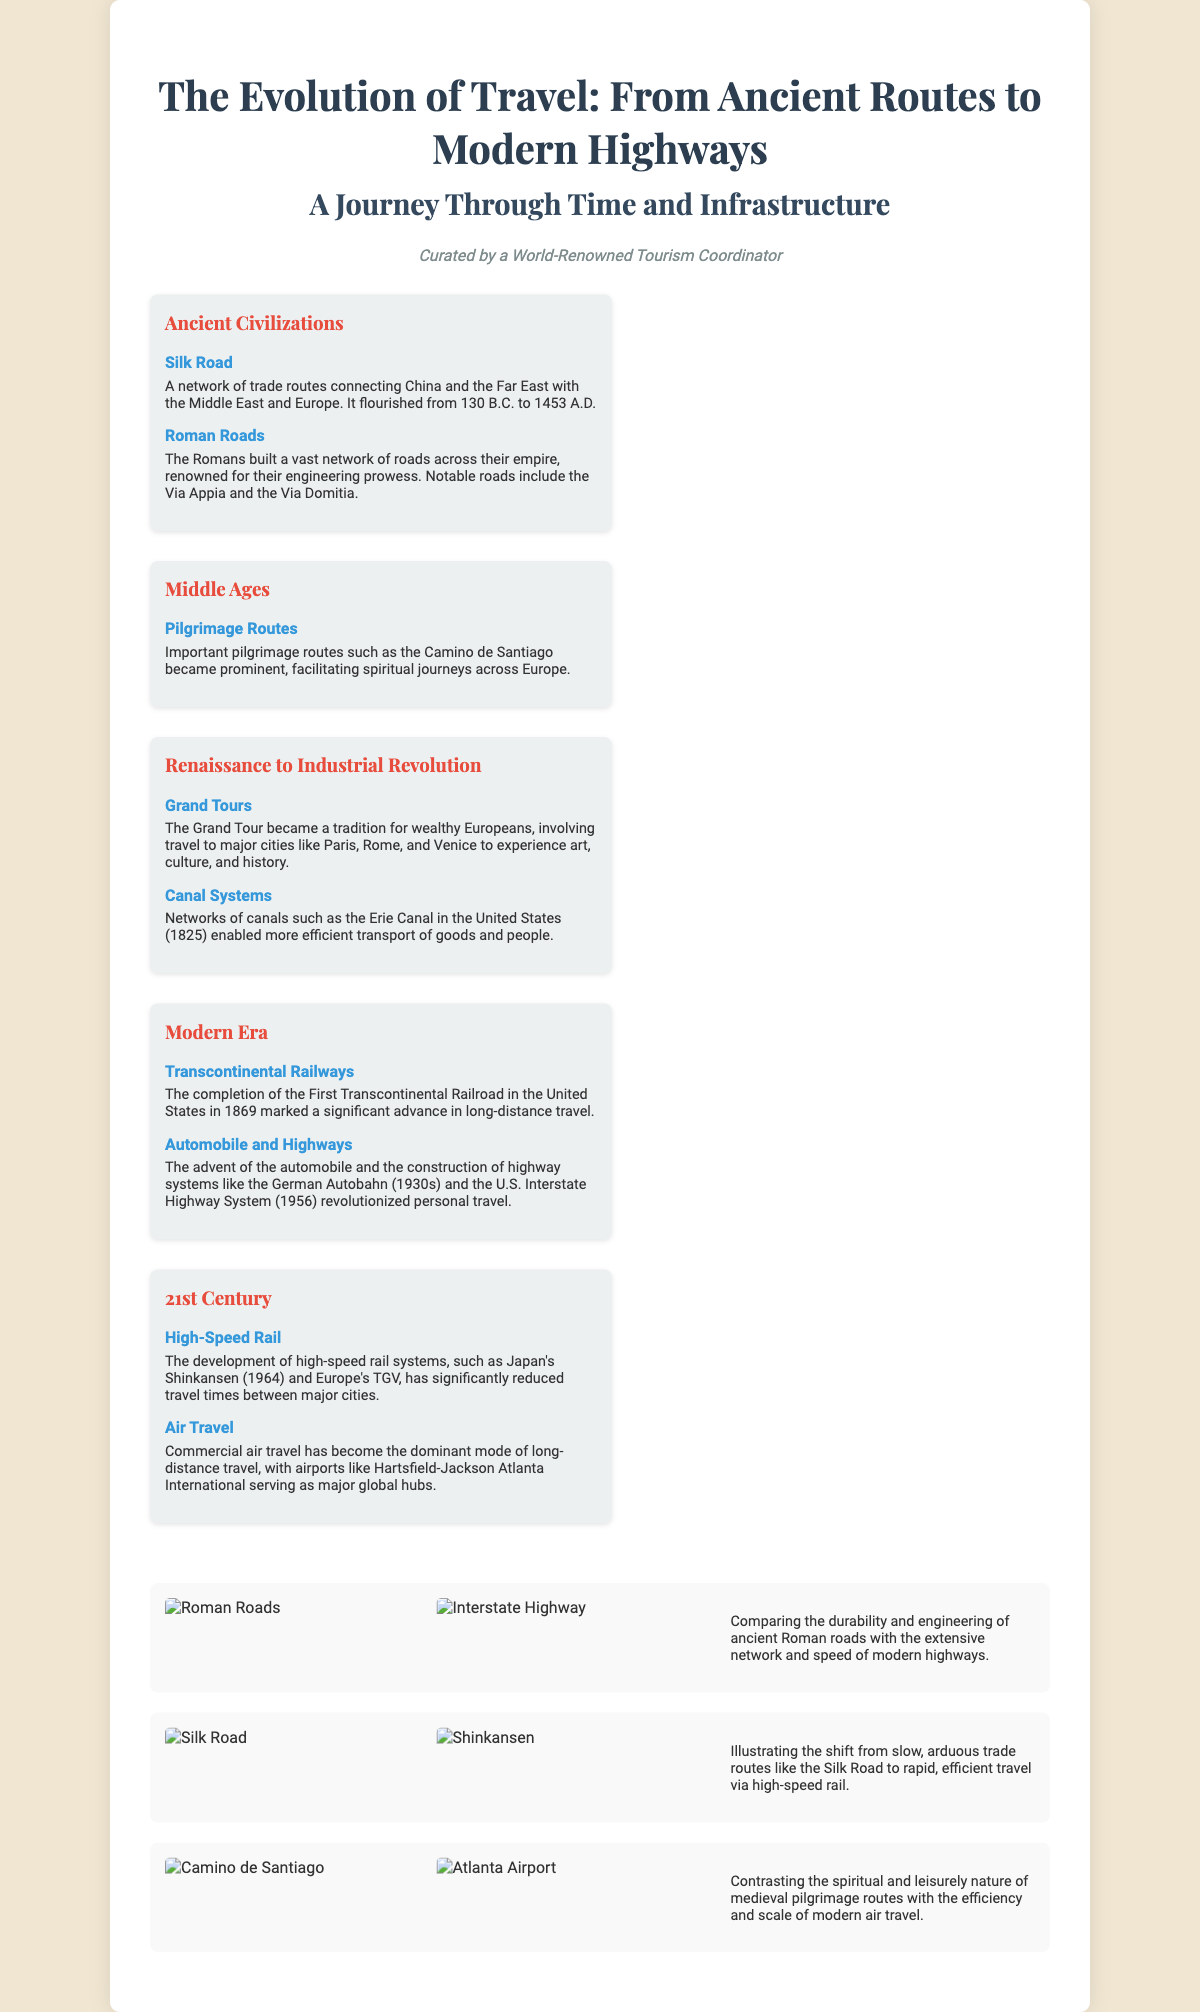What was the primary trade network connecting China to Europe? The document describes the Silk Road as a network of trade routes connecting China to Europe and the Middle East.
Answer: Silk Road What year did the First Transcontinental Railroad complete? The document states that the First Transcontinental Railroad in the United States was completed in 1869.
Answer: 1869 Which infrastructure facilitated spiritual journeys in the Middle Ages? The document mentions that pilgrimage routes like the Camino de Santiago became important for spiritual journeys.
Answer: Pilgrimage Routes What is a notable feature of modern travel highlighted in the document? The document contrasts modern travel's efficiency with high-speed rail systems as a significant feature of modern travel.
Answer: High-Speed Rail Which ancient road is highlighted for its engineering prowess? The document specifically mentions Roman Roads as renowned for their engineering prowess.
Answer: Roman Roads What mode of travel became dominant in the 21st century? According to the document, commercial air travel has become the dominant mode of long-distance travel in the 21st century.
Answer: Air Travel How does the document illustrate the contrast between ancient and modern travel? The document uses visuals and descriptions comparing ancient Roman roads with modern interstate highways to illustrate the contrast.
Answer: Visuals and descriptions What historical period does the Grand Tour belong to? The Grand Tour is mentioned in the context of the Renaissance to Industrial Revolution historical period in the document.
Answer: Renaissance to Industrial Revolution 